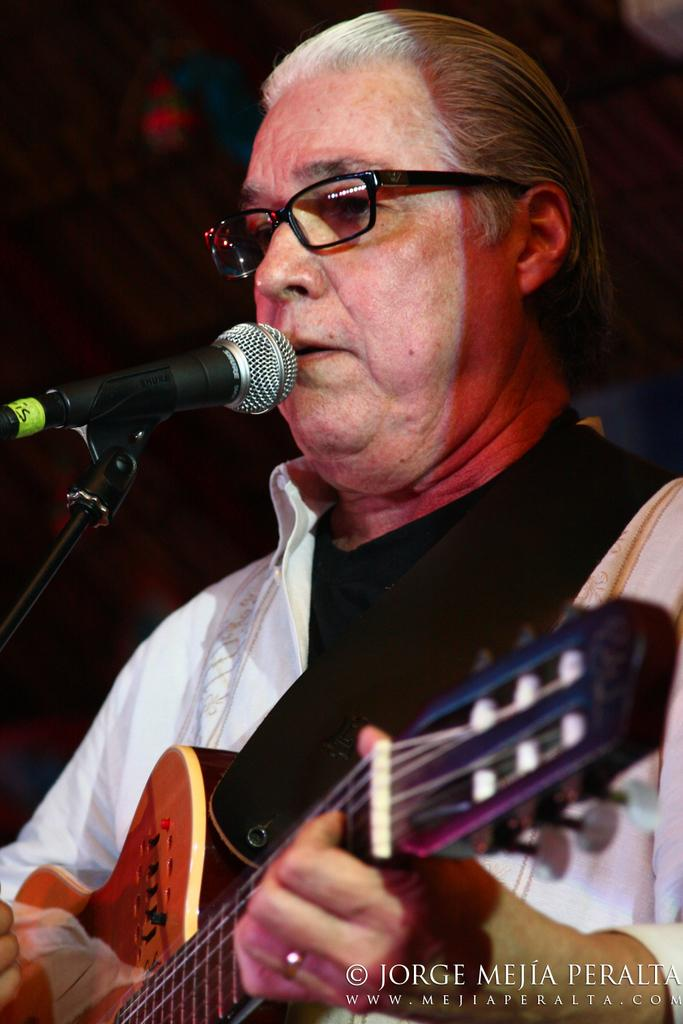What is the man in the image doing? The man is playing a guitar and singing a song. What tool is the man using to amplify his voice? The man is using a microphone. What can be observed about the lighting in the image? The background of the image is dark. How many cherries are on the man's guitar in the image? There are no cherries present on the man's guitar in the image. What type of snow can be seen falling in the background of the image? There is no snow present in the image; the background is dark. 